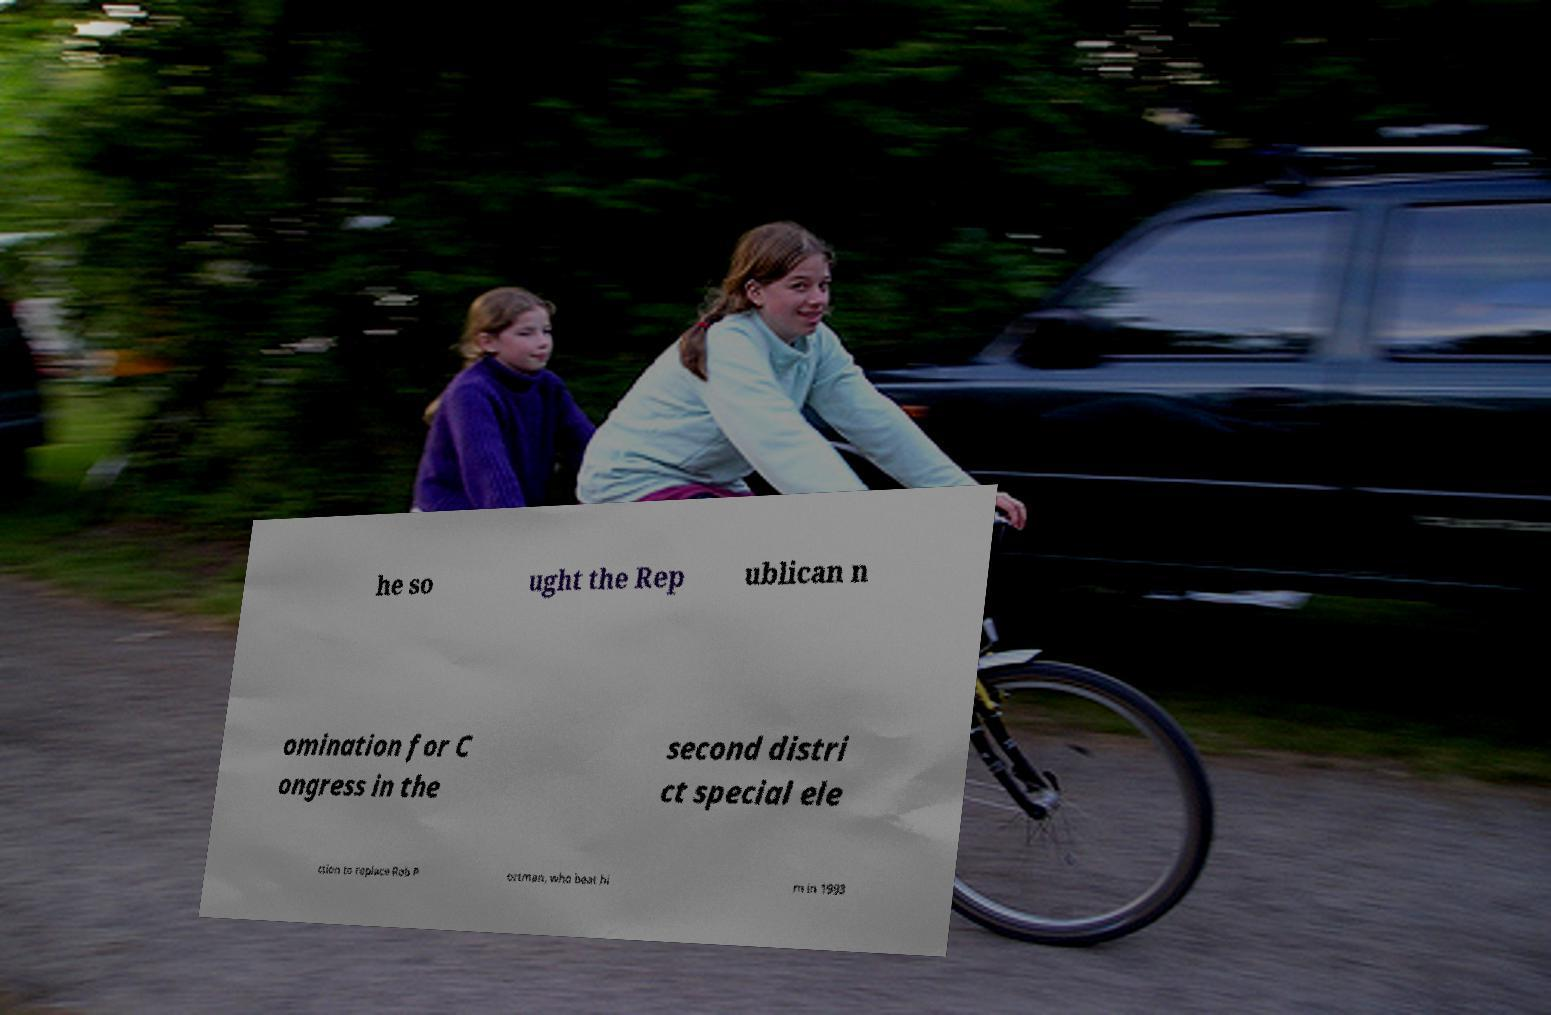Can you read and provide the text displayed in the image?This photo seems to have some interesting text. Can you extract and type it out for me? he so ught the Rep ublican n omination for C ongress in the second distri ct special ele ction to replace Rob P ortman, who beat hi m in 1993 